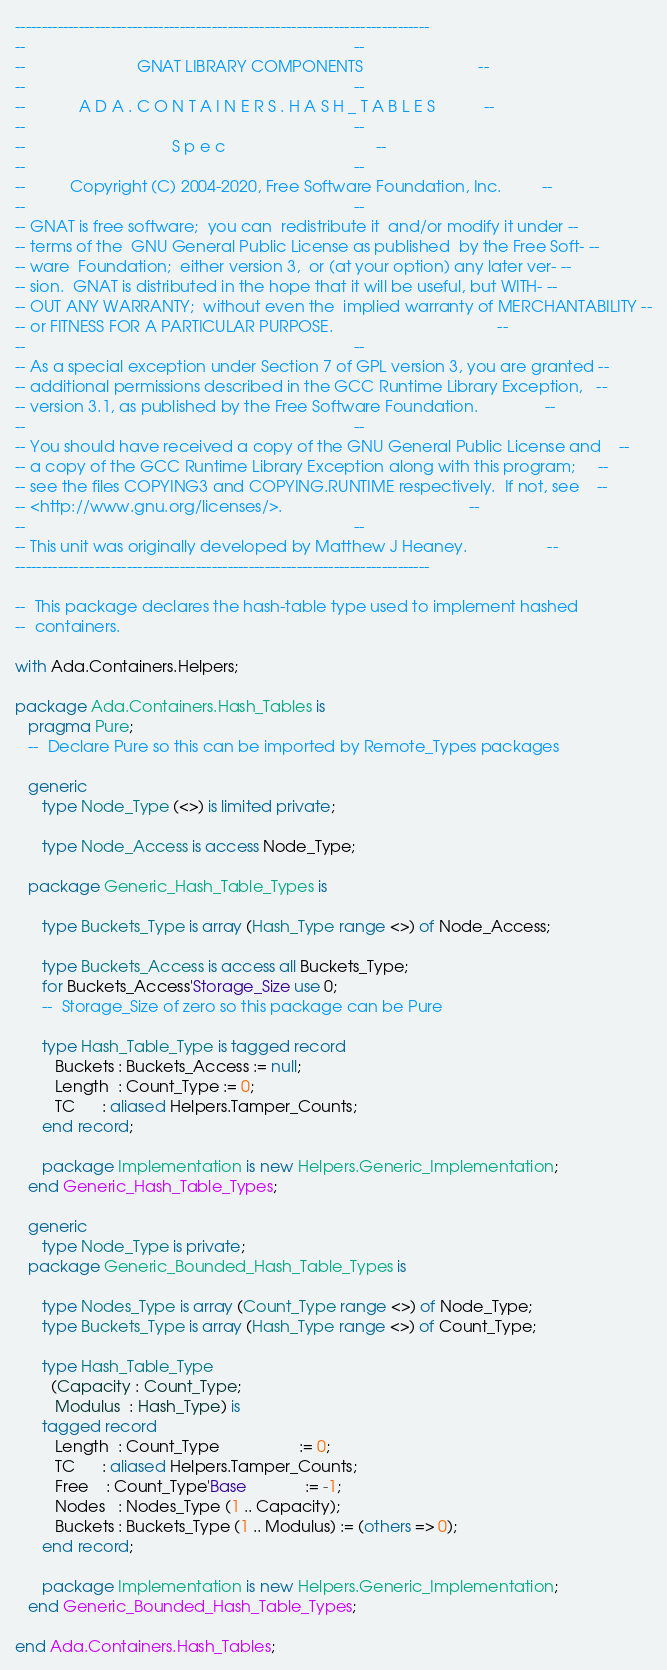<code> <loc_0><loc_0><loc_500><loc_500><_Ada_>------------------------------------------------------------------------------
--                                                                          --
--                         GNAT LIBRARY COMPONENTS                          --
--                                                                          --
--            A D A . C O N T A I N E R S . H A S H _ T A B L E S           --
--                                                                          --
--                                 S p e c                                  --
--                                                                          --
--          Copyright (C) 2004-2020, Free Software Foundation, Inc.         --
--                                                                          --
-- GNAT is free software;  you can  redistribute it  and/or modify it under --
-- terms of the  GNU General Public License as published  by the Free Soft- --
-- ware  Foundation;  either version 3,  or (at your option) any later ver- --
-- sion.  GNAT is distributed in the hope that it will be useful, but WITH- --
-- OUT ANY WARRANTY;  without even the  implied warranty of MERCHANTABILITY --
-- or FITNESS FOR A PARTICULAR PURPOSE.                                     --
--                                                                          --
-- As a special exception under Section 7 of GPL version 3, you are granted --
-- additional permissions described in the GCC Runtime Library Exception,   --
-- version 3.1, as published by the Free Software Foundation.               --
--                                                                          --
-- You should have received a copy of the GNU General Public License and    --
-- a copy of the GCC Runtime Library Exception along with this program;     --
-- see the files COPYING3 and COPYING.RUNTIME respectively.  If not, see    --
-- <http://www.gnu.org/licenses/>.                                          --
--                                                                          --
-- This unit was originally developed by Matthew J Heaney.                  --
------------------------------------------------------------------------------

--  This package declares the hash-table type used to implement hashed
--  containers.

with Ada.Containers.Helpers;

package Ada.Containers.Hash_Tables is
   pragma Pure;
   --  Declare Pure so this can be imported by Remote_Types packages

   generic
      type Node_Type (<>) is limited private;

      type Node_Access is access Node_Type;

   package Generic_Hash_Table_Types is

      type Buckets_Type is array (Hash_Type range <>) of Node_Access;

      type Buckets_Access is access all Buckets_Type;
      for Buckets_Access'Storage_Size use 0;
      --  Storage_Size of zero so this package can be Pure

      type Hash_Table_Type is tagged record
         Buckets : Buckets_Access := null;
         Length  : Count_Type := 0;
         TC      : aliased Helpers.Tamper_Counts;
      end record;

      package Implementation is new Helpers.Generic_Implementation;
   end Generic_Hash_Table_Types;

   generic
      type Node_Type is private;
   package Generic_Bounded_Hash_Table_Types is

      type Nodes_Type is array (Count_Type range <>) of Node_Type;
      type Buckets_Type is array (Hash_Type range <>) of Count_Type;

      type Hash_Table_Type
        (Capacity : Count_Type;
         Modulus  : Hash_Type) is
      tagged record
         Length  : Count_Type                  := 0;
         TC      : aliased Helpers.Tamper_Counts;
         Free    : Count_Type'Base             := -1;
         Nodes   : Nodes_Type (1 .. Capacity);
         Buckets : Buckets_Type (1 .. Modulus) := (others => 0);
      end record;

      package Implementation is new Helpers.Generic_Implementation;
   end Generic_Bounded_Hash_Table_Types;

end Ada.Containers.Hash_Tables;
</code> 